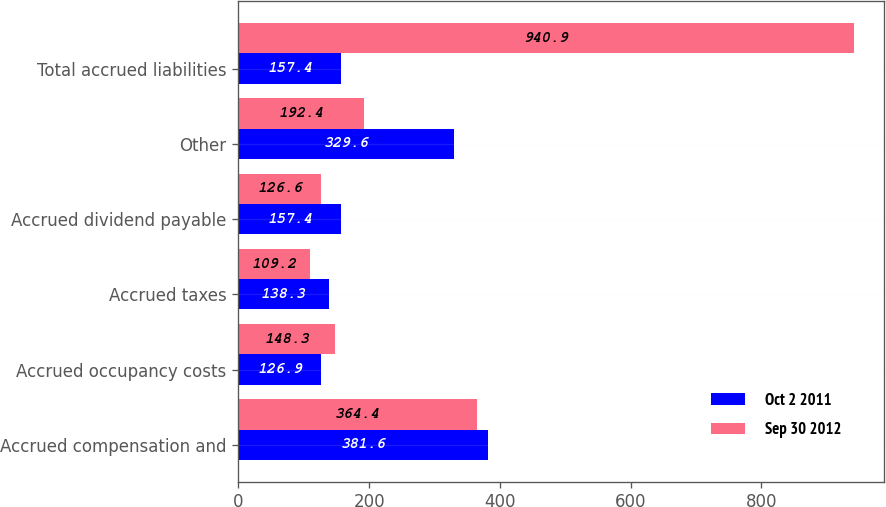Convert chart. <chart><loc_0><loc_0><loc_500><loc_500><stacked_bar_chart><ecel><fcel>Accrued compensation and<fcel>Accrued occupancy costs<fcel>Accrued taxes<fcel>Accrued dividend payable<fcel>Other<fcel>Total accrued liabilities<nl><fcel>Oct 2 2011<fcel>381.6<fcel>126.9<fcel>138.3<fcel>157.4<fcel>329.6<fcel>157.4<nl><fcel>Sep 30 2012<fcel>364.4<fcel>148.3<fcel>109.2<fcel>126.6<fcel>192.4<fcel>940.9<nl></chart> 